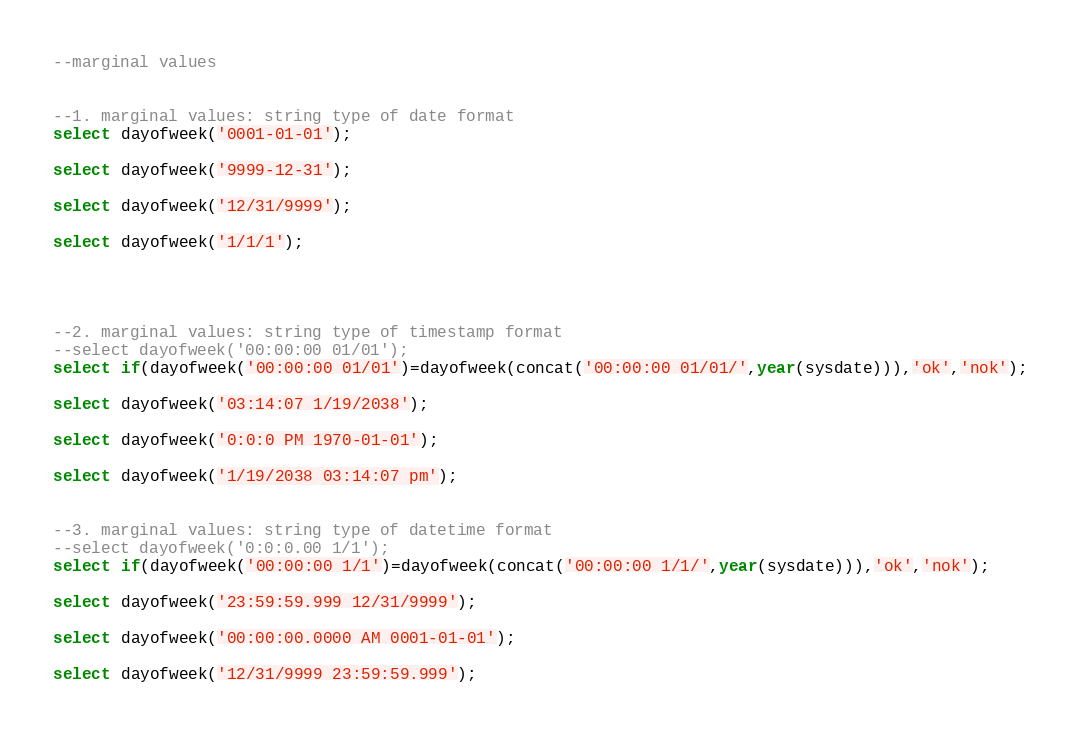<code> <loc_0><loc_0><loc_500><loc_500><_SQL_>--marginal values


--1. marginal values: string type of date format
select dayofweek('0001-01-01');

select dayofweek('9999-12-31');

select dayofweek('12/31/9999');

select dayofweek('1/1/1');




--2. marginal values: string type of timestamp format
--select dayofweek('00:00:00 01/01');
select if(dayofweek('00:00:00 01/01')=dayofweek(concat('00:00:00 01/01/',year(sysdate))),'ok','nok');

select dayofweek('03:14:07 1/19/2038');

select dayofweek('0:0:0 PM 1970-01-01');

select dayofweek('1/19/2038 03:14:07 pm');


--3. marginal values: string type of datetime format
--select dayofweek('0:0:0.00 1/1');
select if(dayofweek('00:00:00 1/1')=dayofweek(concat('00:00:00 1/1/',year(sysdate))),'ok','nok');

select dayofweek('23:59:59.999 12/31/9999');

select dayofweek('00:00:00.0000 AM 0001-01-01');

select dayofweek('12/31/9999 23:59:59.999');



</code> 